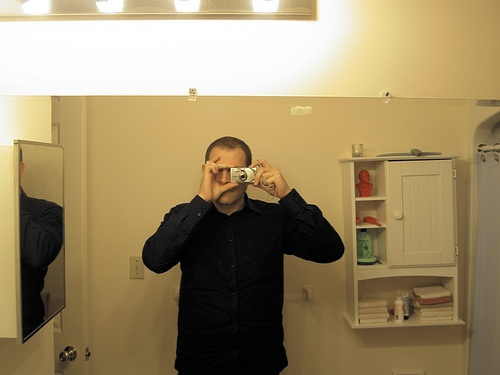Describe the objects in this image and their specific colors. I can see people in ivory, black, tan, and maroon tones, book in ivory, olive, and maroon tones, book in maroon, black, and ivory tones, cup in ivory, tan, and olive tones, and book in ivory and olive tones in this image. 